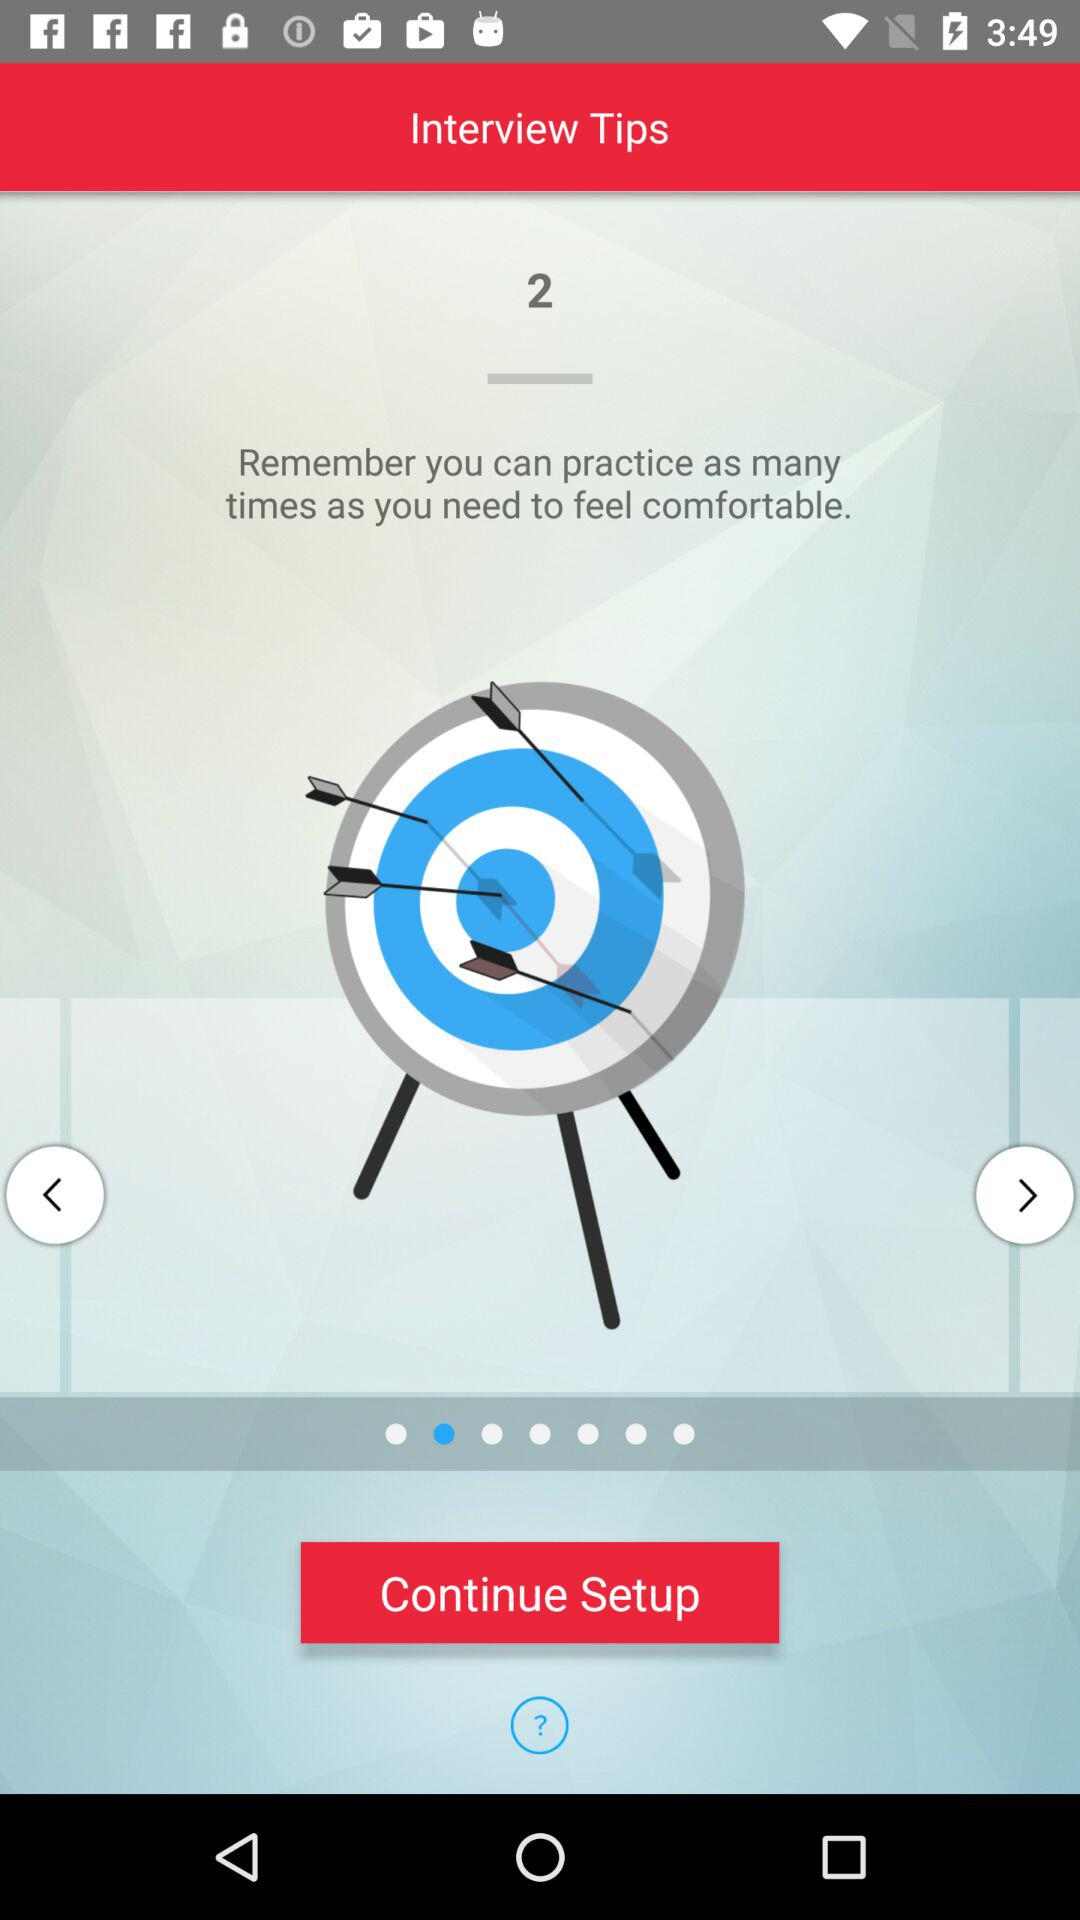What is the tip number? The tip number is 2. 